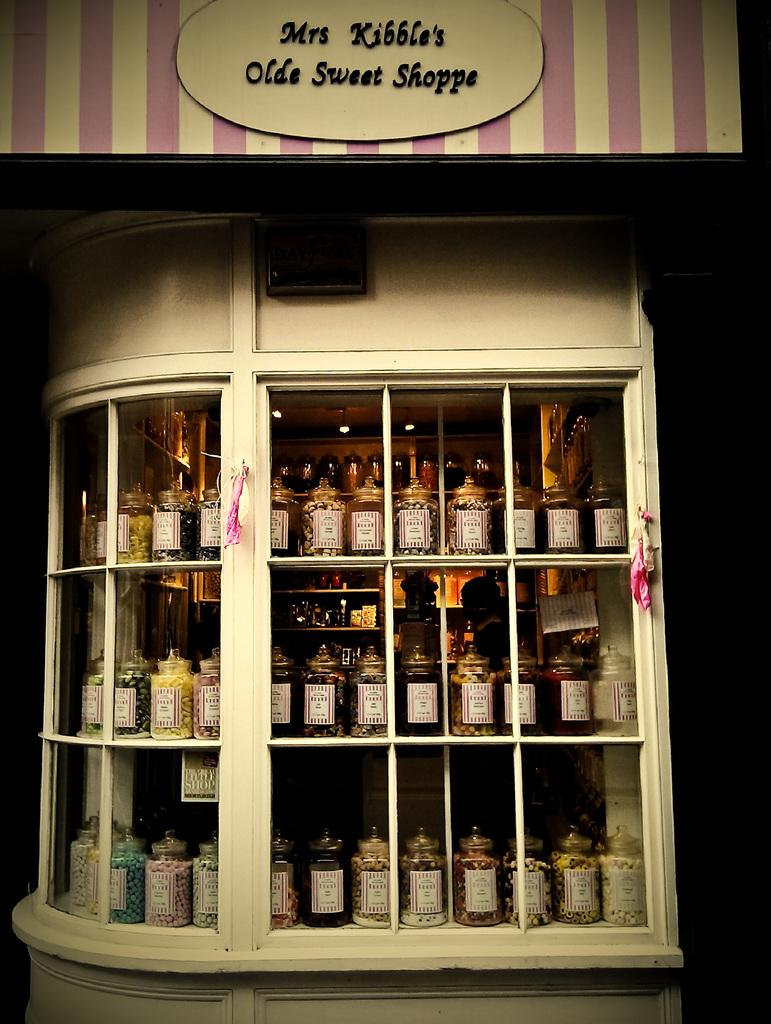<image>
Share a concise interpretation of the image provided. window display of jar candies at mrs kibble's olde sweet shoppe 